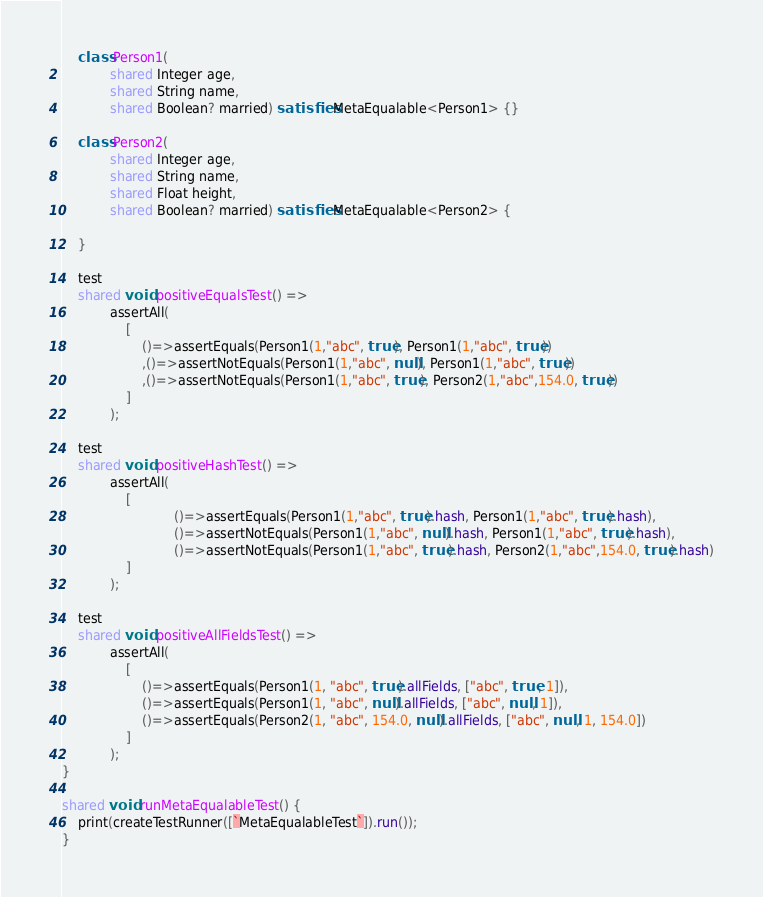<code> <loc_0><loc_0><loc_500><loc_500><_Ceylon_>    class Person1(
            shared Integer age,
            shared String name,
            shared Boolean? married) satisfies MetaEqualable<Person1> {}

    class Person2(
            shared Integer age,
            shared String name,
            shared Float height,
            shared Boolean? married) satisfies MetaEqualable<Person2> {

    }

    test
    shared void positiveEqualsTest() =>
            assertAll(
                [
                    ()=>assertEquals(Person1(1,"abc", true), Person1(1,"abc", true))
                    ,()=>assertNotEquals(Person1(1,"abc", null), Person1(1,"abc", true))
                    ,()=>assertNotEquals(Person1(1,"abc", true), Person2(1,"abc",154.0, true))
                ]
            );

    test
    shared void positiveHashTest() =>
            assertAll(
                [
                            ()=>assertEquals(Person1(1,"abc", true).hash, Person1(1,"abc", true).hash),
                            ()=>assertNotEquals(Person1(1,"abc", null).hash, Person1(1,"abc", true).hash),
                            ()=>assertNotEquals(Person1(1,"abc", true).hash, Person2(1,"abc",154.0, true).hash)
                ]
            );

    test
    shared void positiveAllFieldsTest() =>
            assertAll(
                [
                    ()=>assertEquals(Person1(1, "abc", true).allFields, ["abc", true, 1]),
                    ()=>assertEquals(Person1(1, "abc", null).allFields, ["abc", null, 1]),
                    ()=>assertEquals(Person2(1, "abc", 154.0, null).allFields, ["abc", null, 1, 154.0])
                ]
            );
}

shared void runMetaEqualableTest() {
    print(createTestRunner([`MetaEqualableTest`]).run());
}</code> 